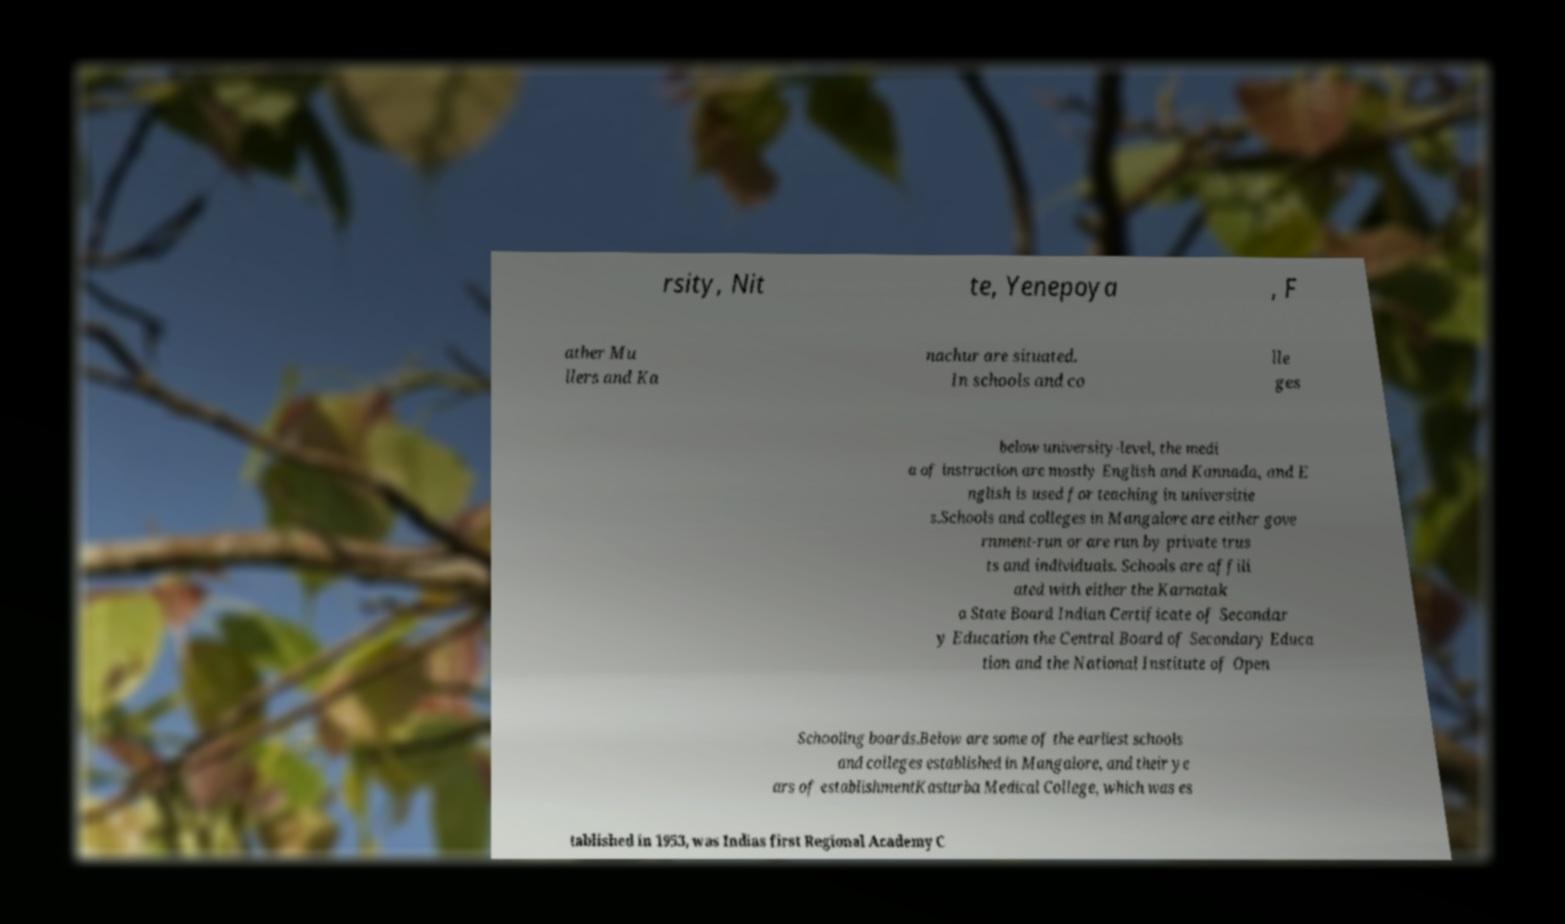Can you read and provide the text displayed in the image?This photo seems to have some interesting text. Can you extract and type it out for me? rsity, Nit te, Yenepoya , F ather Mu llers and Ka nachur are situated. In schools and co lle ges below university-level, the medi a of instruction are mostly English and Kannada, and E nglish is used for teaching in universitie s.Schools and colleges in Mangalore are either gove rnment-run or are run by private trus ts and individuals. Schools are affili ated with either the Karnatak a State Board Indian Certificate of Secondar y Education the Central Board of Secondary Educa tion and the National Institute of Open Schooling boards.Below are some of the earliest schools and colleges established in Mangalore, and their ye ars of establishmentKasturba Medical College, which was es tablished in 1953, was Indias first Regional Academy C 